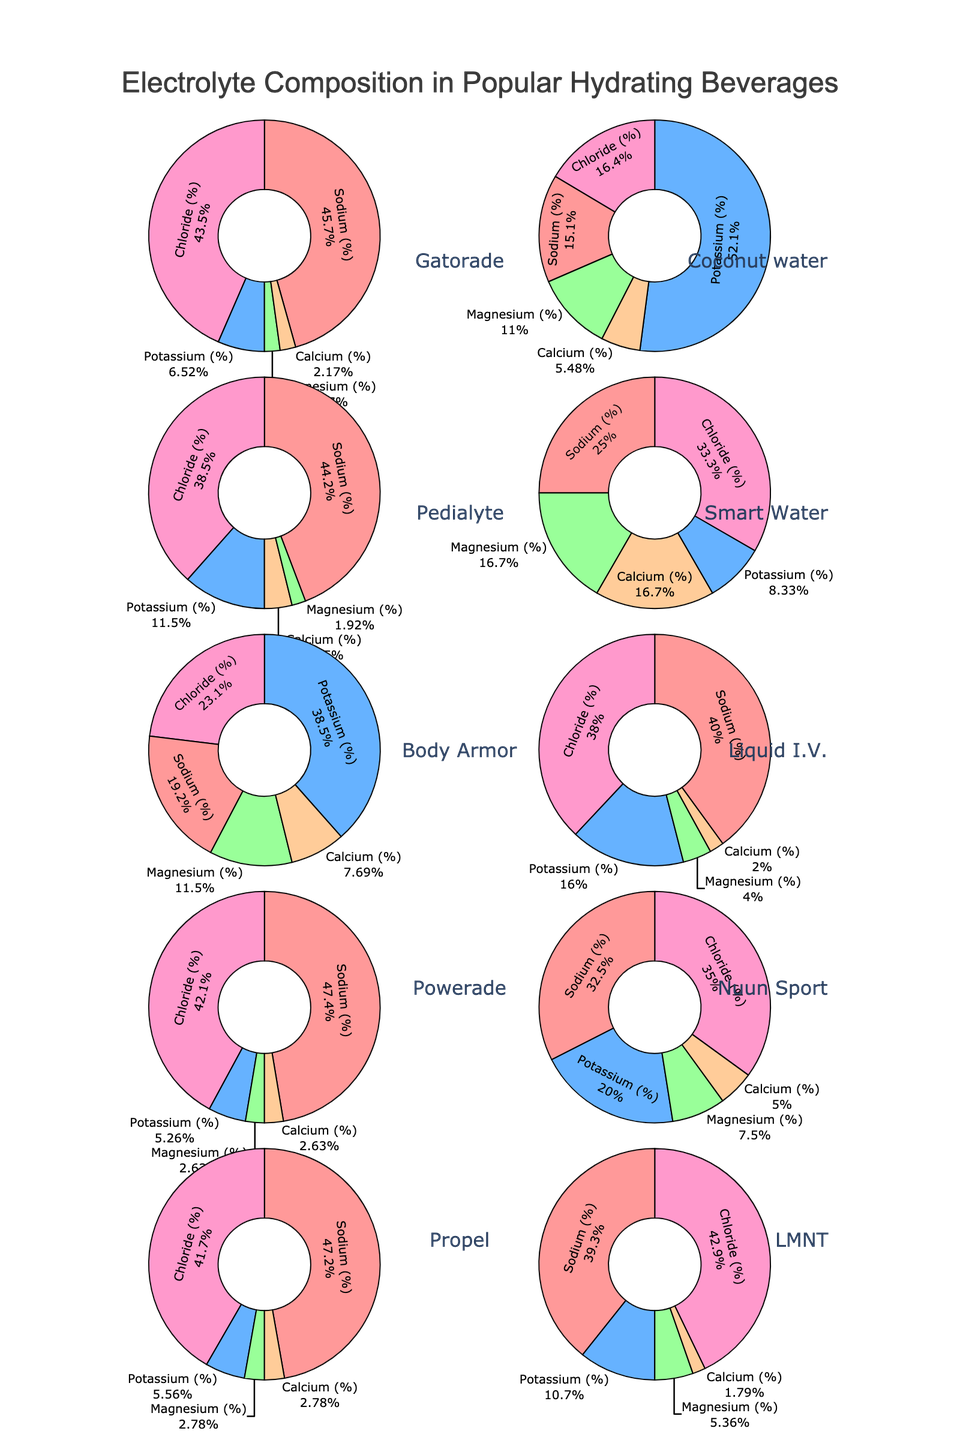What percentage of sodium is in Gatorade compared to Pedialyte? Gatorade has 21% sodium and Pedialyte has 23% sodium. So the comparison is 21% vs 23%.
Answer: 21% vs 23% Which beverage has the highest percentage of potassium? By observing the pie charts, Coconut water has the highest percentage of potassium at 38%.
Answer: Coconut water What is the total percentage of chloride in Liquid I.V. and Propel combined? Liquid I.V. has 19% chloride and Propel has 15% chloride. Adding them, 19% + 15% = 34%.
Answer: 34% Is the percentage of magnesium higher in Body Armor or Smart Water? Body Armor contains 3% magnesium while Smart Water contains 2% magnesium. 3% is greater than 2%.
Answer: Body Armor Which beverage has the lowest overall percentage of electrolytes? Smart Water has much lower percentages of each electrolyte compared to other beverages.
Answer: Smart Water What is the sum of the percentages of sodium, potassium, and magnesium in Nuun Sport? Summing up sodium (13%), potassium (8%), and magnesium (3%) in Nuun Sport equals 13% + 8% + 3% = 24%.
Answer: 24% Are there more electrolytes in terms of calcium in Gatorade or Liquid I.V.? Both Gatorade and Liquid I.V. have 1% calcium.
Answer: Equal Which electrolyte is present in the largest proportion in Body Armor? The pie chart for Body Armor shows potassium having the largest proportion at 10%.
Answer: Potassium Which two beverages have the closest percentage of chloride? Gatorade and Pedialyte each have 20% chloride, making them the closest in percentage.
Answer: Gatorade and Pedialyte 